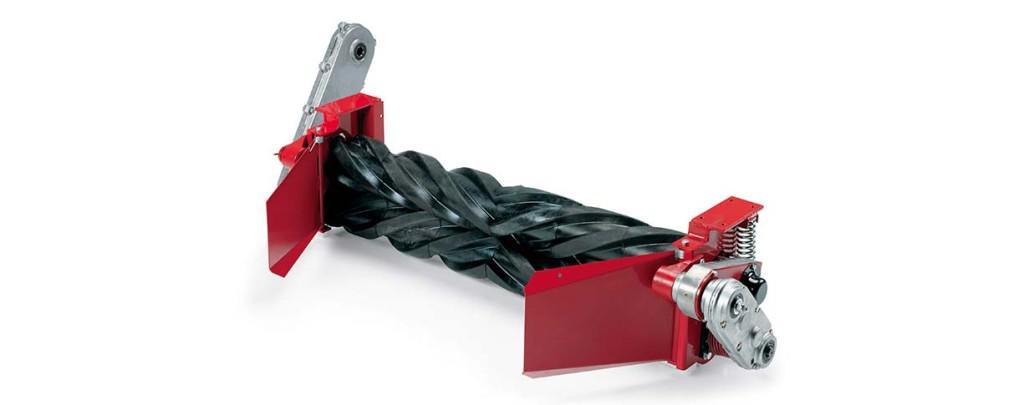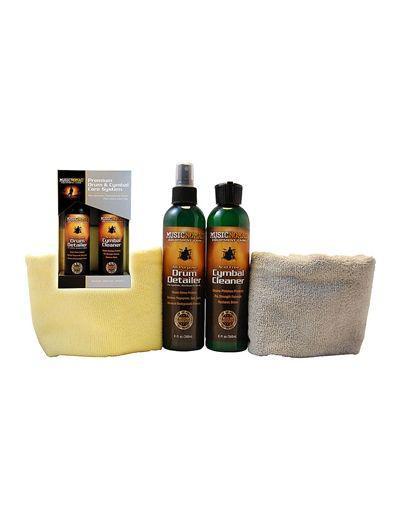The first image is the image on the left, the second image is the image on the right. For the images displayed, is the sentence "There are more containers in the image on the right." factually correct? Answer yes or no. Yes. The first image is the image on the left, the second image is the image on the right. Assess this claim about the two images: "There is a shiny silver machine in one image, and something red/orange in the other.". Correct or not? Answer yes or no. No. 